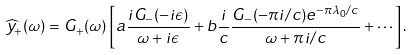Convert formula to latex. <formula><loc_0><loc_0><loc_500><loc_500>\widehat { y } _ { + } ( \omega ) = G _ { + } ( \omega ) \left [ a \frac { i G _ { - } ( - i \epsilon ) } { \omega + i \epsilon } + b \frac { i } { c } \frac { G _ { - } ( - \pi i / c ) e ^ { - \pi \lambda _ { 0 } / c } } { \omega + \pi i / c } + \cdots \right ] .</formula> 